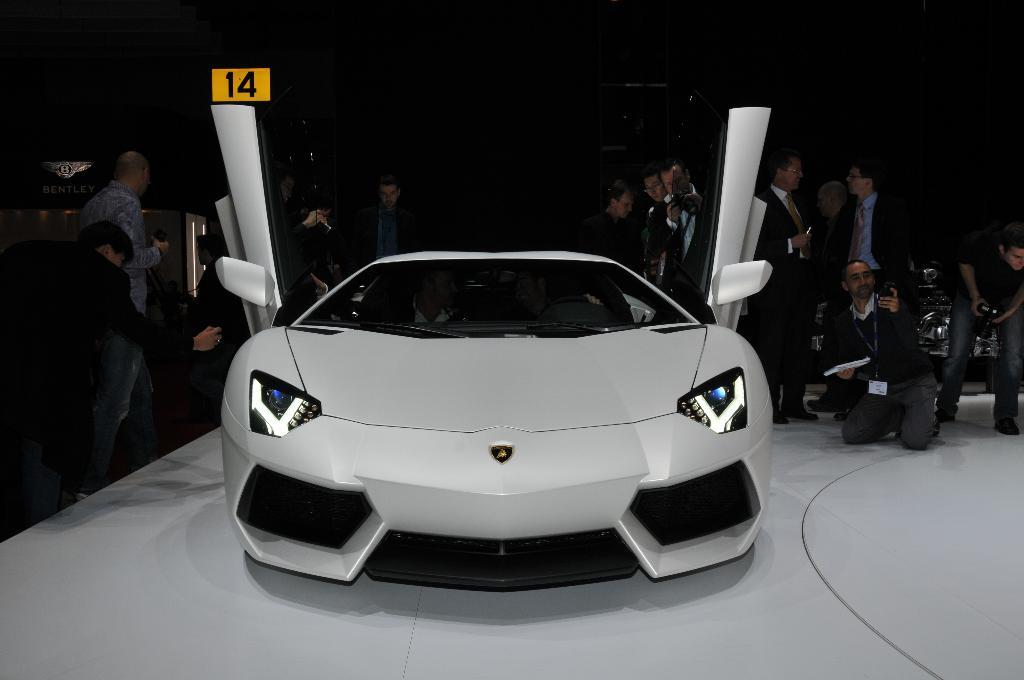What can be seen in the image related to transportation? There are vehicles in the image. Can you describe the appearance of the vehicles? The vehicles are in different colors. What else is present in the image besides the vehicles? There is a group of people in the image. What are some people doing in the image? Some people are holding something. How would you describe the lighting in the image? The image is dark. What type of war is depicted in the image? There is no war depicted in the image; it features vehicles and people. What kind of attraction can be seen in the image? There is no attraction present in the image; it focuses on vehicles and people. 